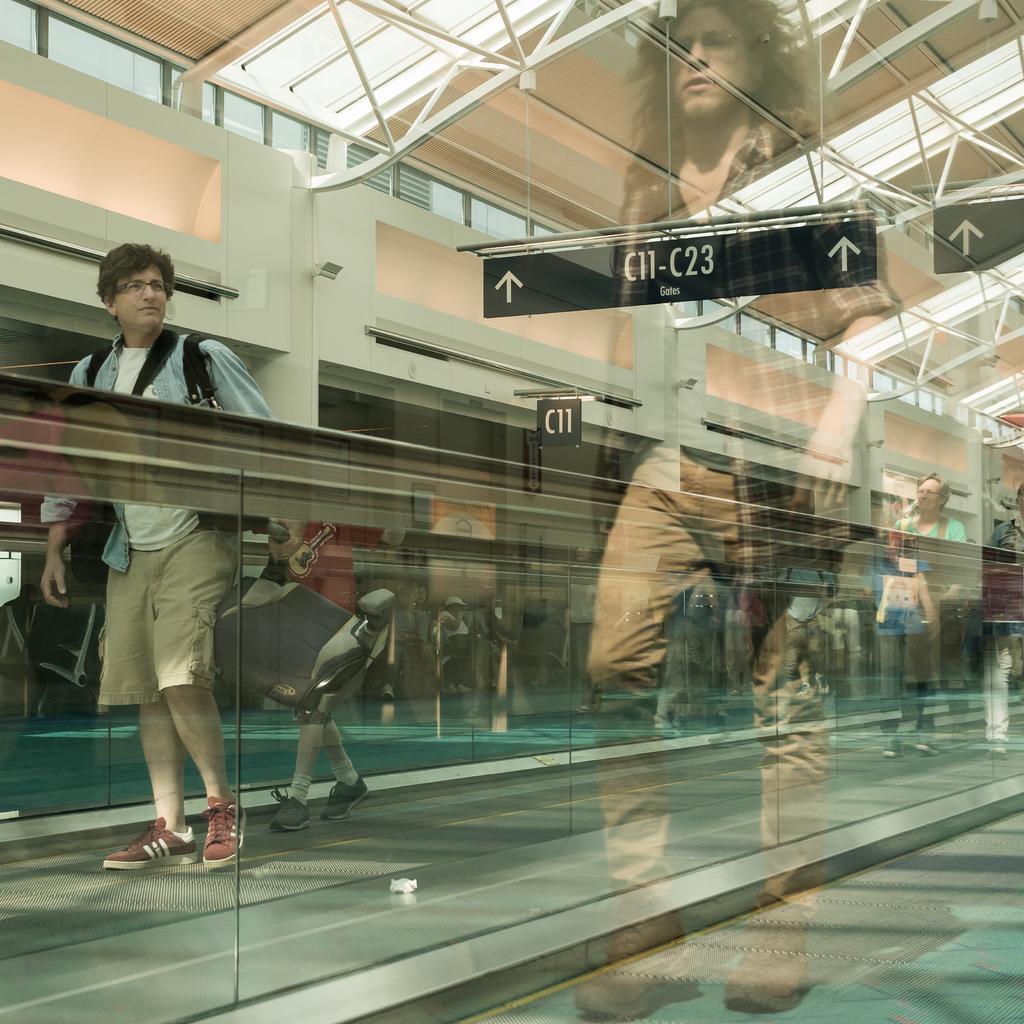How would you summarize this image in a sentence or two? In this image I can see the person and the person is wearing blue, white and brown color dress. In front I can see the glass wall. In the background the wall is in white color. 